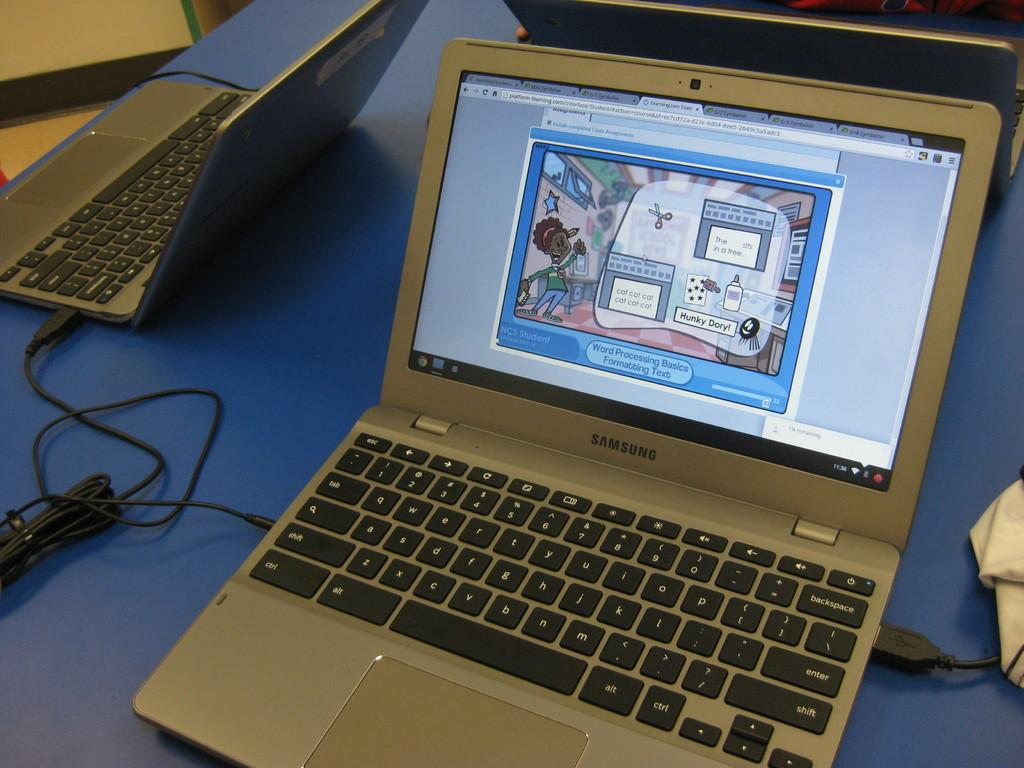<image>
Give a short and clear explanation of the subsequent image. a silver laptop that is labeled as a samsung on it 